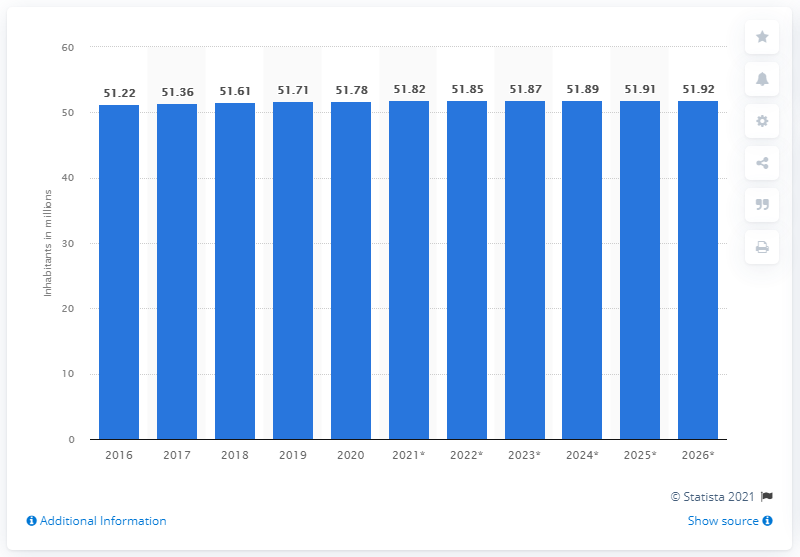List a handful of essential elements in this visual. In 2020, the population of South Korea was approximately 51.92 million. The population of South Korea is expected to come to an end in 2020. 